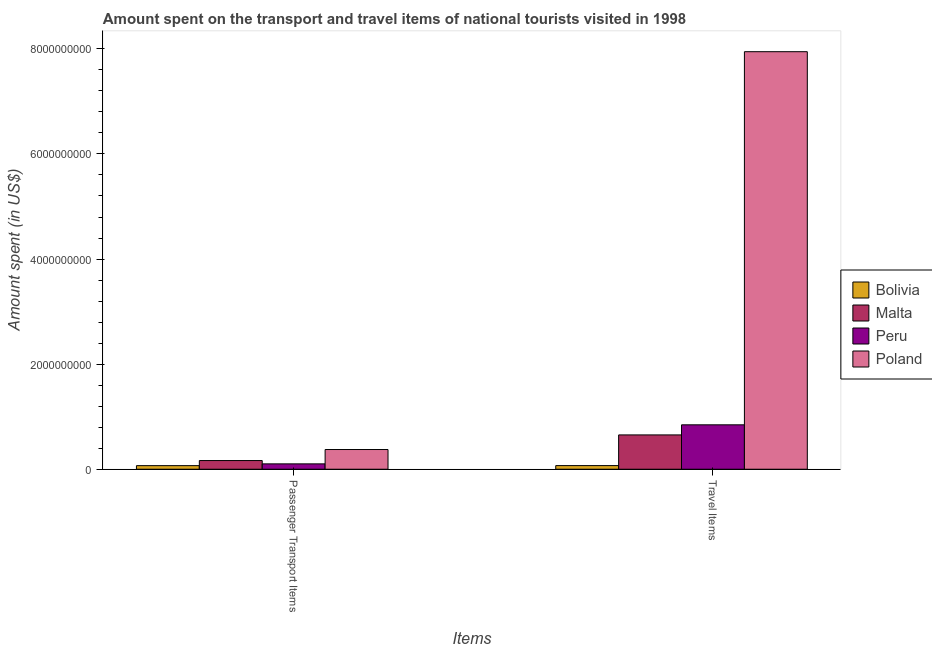How many different coloured bars are there?
Make the answer very short. 4. How many groups of bars are there?
Make the answer very short. 2. Are the number of bars per tick equal to the number of legend labels?
Your answer should be compact. Yes. What is the label of the 1st group of bars from the left?
Offer a terse response. Passenger Transport Items. What is the amount spent on passenger transport items in Poland?
Provide a succinct answer. 3.75e+08. Across all countries, what is the maximum amount spent in travel items?
Offer a terse response. 7.95e+09. Across all countries, what is the minimum amount spent on passenger transport items?
Your answer should be very brief. 6.80e+07. In which country was the amount spent in travel items minimum?
Ensure brevity in your answer.  Bolivia. What is the total amount spent in travel items in the graph?
Offer a terse response. 9.51e+09. What is the difference between the amount spent in travel items in Bolivia and that in Poland?
Make the answer very short. -7.88e+09. What is the difference between the amount spent in travel items in Malta and the amount spent on passenger transport items in Peru?
Make the answer very short. 5.51e+08. What is the average amount spent on passenger transport items per country?
Your response must be concise. 1.78e+08. What is the difference between the amount spent in travel items and amount spent on passenger transport items in Malta?
Provide a succinct answer. 4.88e+08. In how many countries, is the amount spent on passenger transport items greater than 6400000000 US$?
Offer a very short reply. 0. What is the ratio of the amount spent on passenger transport items in Bolivia to that in Malta?
Offer a terse response. 0.41. Is the amount spent in travel items in Poland less than that in Malta?
Offer a very short reply. No. What does the 2nd bar from the right in Travel Items represents?
Your response must be concise. Peru. Are all the bars in the graph horizontal?
Your answer should be compact. No. Are the values on the major ticks of Y-axis written in scientific E-notation?
Keep it short and to the point. No. Where does the legend appear in the graph?
Keep it short and to the point. Center right. How many legend labels are there?
Provide a succinct answer. 4. How are the legend labels stacked?
Your answer should be very brief. Vertical. What is the title of the graph?
Give a very brief answer. Amount spent on the transport and travel items of national tourists visited in 1998. Does "Canada" appear as one of the legend labels in the graph?
Give a very brief answer. No. What is the label or title of the X-axis?
Provide a short and direct response. Items. What is the label or title of the Y-axis?
Keep it short and to the point. Amount spent (in US$). What is the Amount spent (in US$) of Bolivia in Passenger Transport Items?
Keep it short and to the point. 6.80e+07. What is the Amount spent (in US$) in Malta in Passenger Transport Items?
Provide a short and direct response. 1.65e+08. What is the Amount spent (in US$) in Peru in Passenger Transport Items?
Keep it short and to the point. 1.02e+08. What is the Amount spent (in US$) in Poland in Passenger Transport Items?
Provide a short and direct response. 3.75e+08. What is the Amount spent (in US$) in Bolivia in Travel Items?
Your response must be concise. 6.90e+07. What is the Amount spent (in US$) in Malta in Travel Items?
Offer a terse response. 6.53e+08. What is the Amount spent (in US$) in Peru in Travel Items?
Your response must be concise. 8.45e+08. What is the Amount spent (in US$) in Poland in Travel Items?
Provide a short and direct response. 7.95e+09. Across all Items, what is the maximum Amount spent (in US$) in Bolivia?
Your answer should be very brief. 6.90e+07. Across all Items, what is the maximum Amount spent (in US$) in Malta?
Provide a short and direct response. 6.53e+08. Across all Items, what is the maximum Amount spent (in US$) of Peru?
Provide a succinct answer. 8.45e+08. Across all Items, what is the maximum Amount spent (in US$) in Poland?
Offer a terse response. 7.95e+09. Across all Items, what is the minimum Amount spent (in US$) in Bolivia?
Keep it short and to the point. 6.80e+07. Across all Items, what is the minimum Amount spent (in US$) of Malta?
Give a very brief answer. 1.65e+08. Across all Items, what is the minimum Amount spent (in US$) in Peru?
Offer a very short reply. 1.02e+08. Across all Items, what is the minimum Amount spent (in US$) in Poland?
Give a very brief answer. 3.75e+08. What is the total Amount spent (in US$) in Bolivia in the graph?
Make the answer very short. 1.37e+08. What is the total Amount spent (in US$) in Malta in the graph?
Provide a short and direct response. 8.18e+08. What is the total Amount spent (in US$) in Peru in the graph?
Give a very brief answer. 9.47e+08. What is the total Amount spent (in US$) of Poland in the graph?
Make the answer very short. 8.32e+09. What is the difference between the Amount spent (in US$) of Bolivia in Passenger Transport Items and that in Travel Items?
Your response must be concise. -1.00e+06. What is the difference between the Amount spent (in US$) in Malta in Passenger Transport Items and that in Travel Items?
Provide a succinct answer. -4.88e+08. What is the difference between the Amount spent (in US$) in Peru in Passenger Transport Items and that in Travel Items?
Offer a very short reply. -7.43e+08. What is the difference between the Amount spent (in US$) of Poland in Passenger Transport Items and that in Travel Items?
Your answer should be compact. -7.57e+09. What is the difference between the Amount spent (in US$) of Bolivia in Passenger Transport Items and the Amount spent (in US$) of Malta in Travel Items?
Offer a very short reply. -5.85e+08. What is the difference between the Amount spent (in US$) in Bolivia in Passenger Transport Items and the Amount spent (in US$) in Peru in Travel Items?
Offer a terse response. -7.77e+08. What is the difference between the Amount spent (in US$) in Bolivia in Passenger Transport Items and the Amount spent (in US$) in Poland in Travel Items?
Your response must be concise. -7.88e+09. What is the difference between the Amount spent (in US$) of Malta in Passenger Transport Items and the Amount spent (in US$) of Peru in Travel Items?
Offer a terse response. -6.80e+08. What is the difference between the Amount spent (in US$) in Malta in Passenger Transport Items and the Amount spent (in US$) in Poland in Travel Items?
Give a very brief answer. -7.78e+09. What is the difference between the Amount spent (in US$) of Peru in Passenger Transport Items and the Amount spent (in US$) of Poland in Travel Items?
Give a very brief answer. -7.84e+09. What is the average Amount spent (in US$) in Bolivia per Items?
Make the answer very short. 6.85e+07. What is the average Amount spent (in US$) of Malta per Items?
Your answer should be compact. 4.09e+08. What is the average Amount spent (in US$) in Peru per Items?
Ensure brevity in your answer.  4.74e+08. What is the average Amount spent (in US$) in Poland per Items?
Your response must be concise. 4.16e+09. What is the difference between the Amount spent (in US$) of Bolivia and Amount spent (in US$) of Malta in Passenger Transport Items?
Provide a succinct answer. -9.70e+07. What is the difference between the Amount spent (in US$) in Bolivia and Amount spent (in US$) in Peru in Passenger Transport Items?
Provide a short and direct response. -3.40e+07. What is the difference between the Amount spent (in US$) in Bolivia and Amount spent (in US$) in Poland in Passenger Transport Items?
Offer a terse response. -3.07e+08. What is the difference between the Amount spent (in US$) in Malta and Amount spent (in US$) in Peru in Passenger Transport Items?
Keep it short and to the point. 6.30e+07. What is the difference between the Amount spent (in US$) of Malta and Amount spent (in US$) of Poland in Passenger Transport Items?
Ensure brevity in your answer.  -2.10e+08. What is the difference between the Amount spent (in US$) of Peru and Amount spent (in US$) of Poland in Passenger Transport Items?
Offer a terse response. -2.73e+08. What is the difference between the Amount spent (in US$) in Bolivia and Amount spent (in US$) in Malta in Travel Items?
Ensure brevity in your answer.  -5.84e+08. What is the difference between the Amount spent (in US$) in Bolivia and Amount spent (in US$) in Peru in Travel Items?
Ensure brevity in your answer.  -7.76e+08. What is the difference between the Amount spent (in US$) in Bolivia and Amount spent (in US$) in Poland in Travel Items?
Your answer should be compact. -7.88e+09. What is the difference between the Amount spent (in US$) of Malta and Amount spent (in US$) of Peru in Travel Items?
Offer a terse response. -1.92e+08. What is the difference between the Amount spent (in US$) in Malta and Amount spent (in US$) in Poland in Travel Items?
Your answer should be very brief. -7.29e+09. What is the difference between the Amount spent (in US$) in Peru and Amount spent (in US$) in Poland in Travel Items?
Provide a short and direct response. -7.10e+09. What is the ratio of the Amount spent (in US$) of Bolivia in Passenger Transport Items to that in Travel Items?
Provide a succinct answer. 0.99. What is the ratio of the Amount spent (in US$) in Malta in Passenger Transport Items to that in Travel Items?
Give a very brief answer. 0.25. What is the ratio of the Amount spent (in US$) in Peru in Passenger Transport Items to that in Travel Items?
Ensure brevity in your answer.  0.12. What is the ratio of the Amount spent (in US$) of Poland in Passenger Transport Items to that in Travel Items?
Give a very brief answer. 0.05. What is the difference between the highest and the second highest Amount spent (in US$) of Bolivia?
Keep it short and to the point. 1.00e+06. What is the difference between the highest and the second highest Amount spent (in US$) of Malta?
Your answer should be compact. 4.88e+08. What is the difference between the highest and the second highest Amount spent (in US$) in Peru?
Make the answer very short. 7.43e+08. What is the difference between the highest and the second highest Amount spent (in US$) in Poland?
Offer a very short reply. 7.57e+09. What is the difference between the highest and the lowest Amount spent (in US$) of Bolivia?
Keep it short and to the point. 1.00e+06. What is the difference between the highest and the lowest Amount spent (in US$) in Malta?
Give a very brief answer. 4.88e+08. What is the difference between the highest and the lowest Amount spent (in US$) in Peru?
Offer a terse response. 7.43e+08. What is the difference between the highest and the lowest Amount spent (in US$) in Poland?
Ensure brevity in your answer.  7.57e+09. 